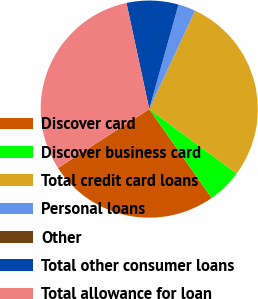Convert chart to OTSL. <chart><loc_0><loc_0><loc_500><loc_500><pie_chart><fcel>Discover card<fcel>Discover business card<fcel>Total credit card loans<fcel>Personal loans<fcel>Other<fcel>Total other consumer loans<fcel>Total allowance for loan<nl><fcel>25.62%<fcel>5.15%<fcel>28.18%<fcel>2.58%<fcel>0.01%<fcel>7.71%<fcel>30.75%<nl></chart> 